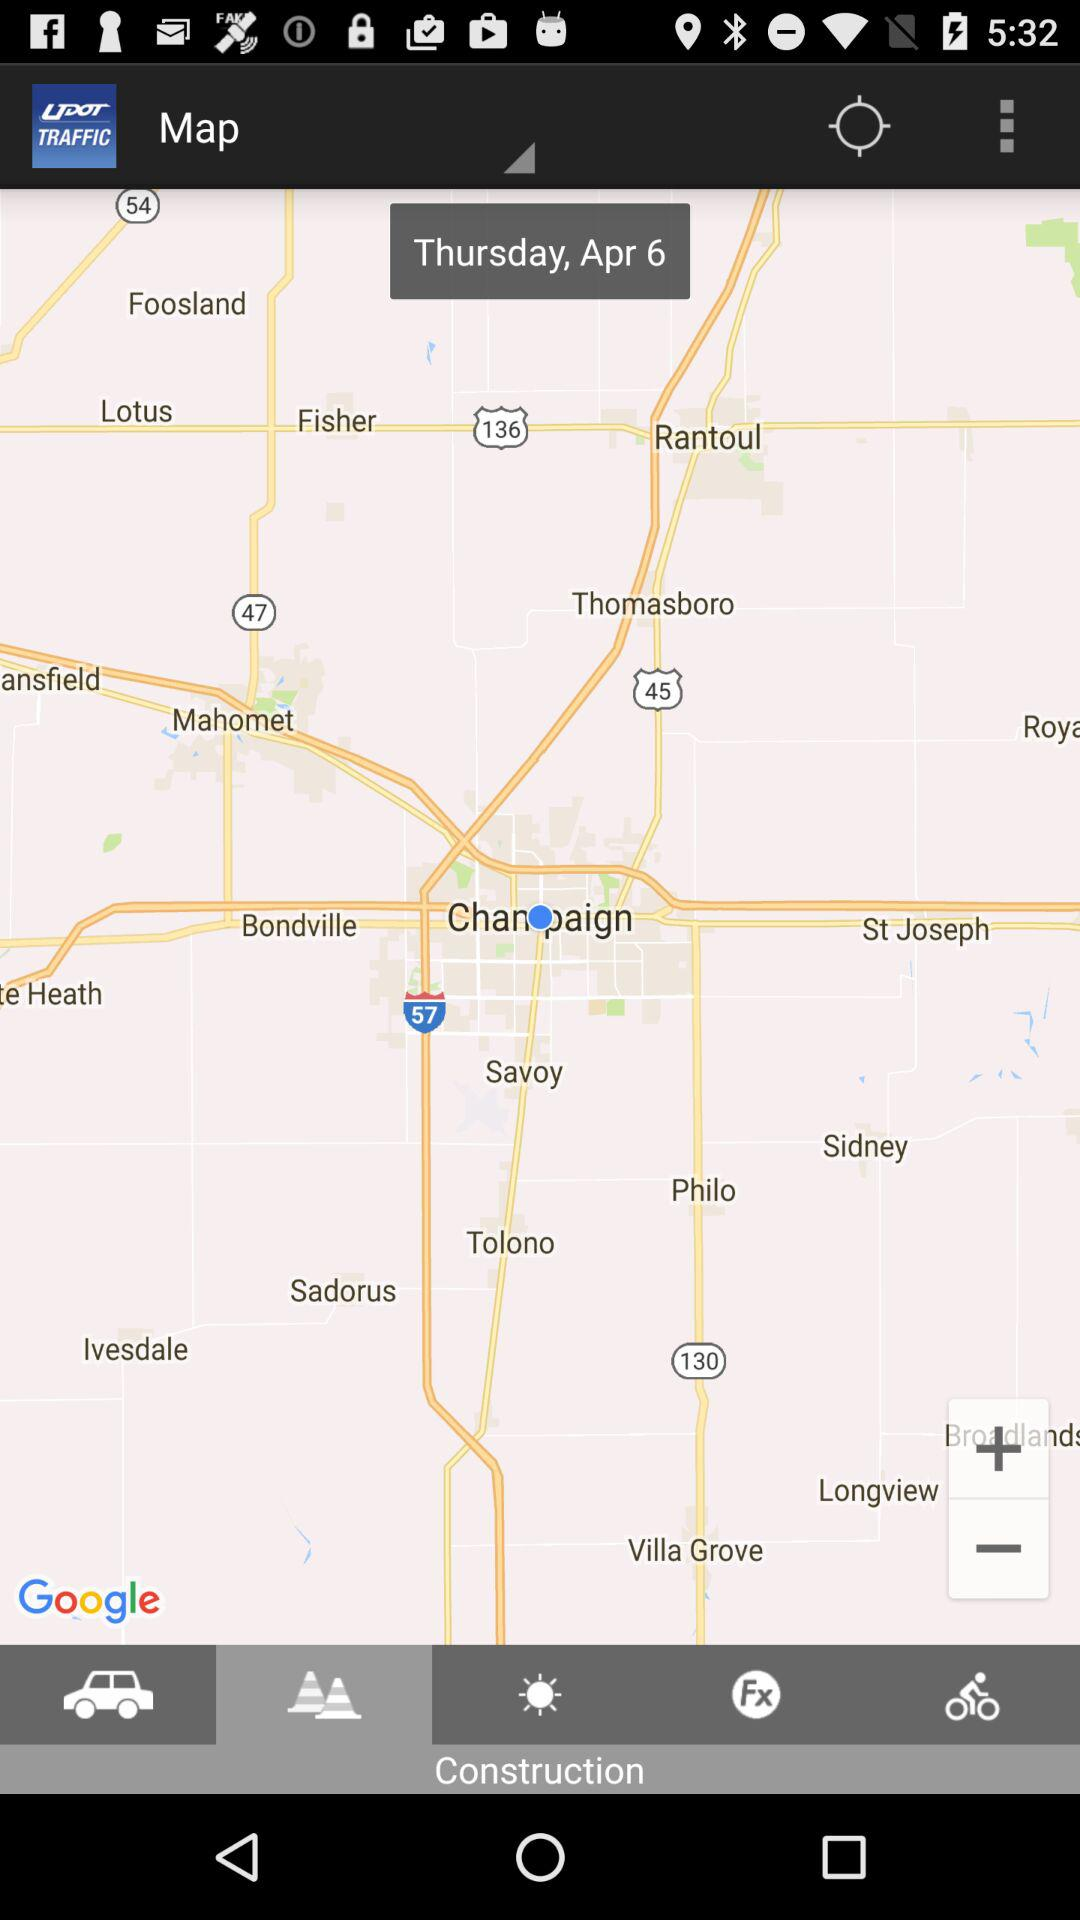What is the selected day? The selected day is Thursday. 